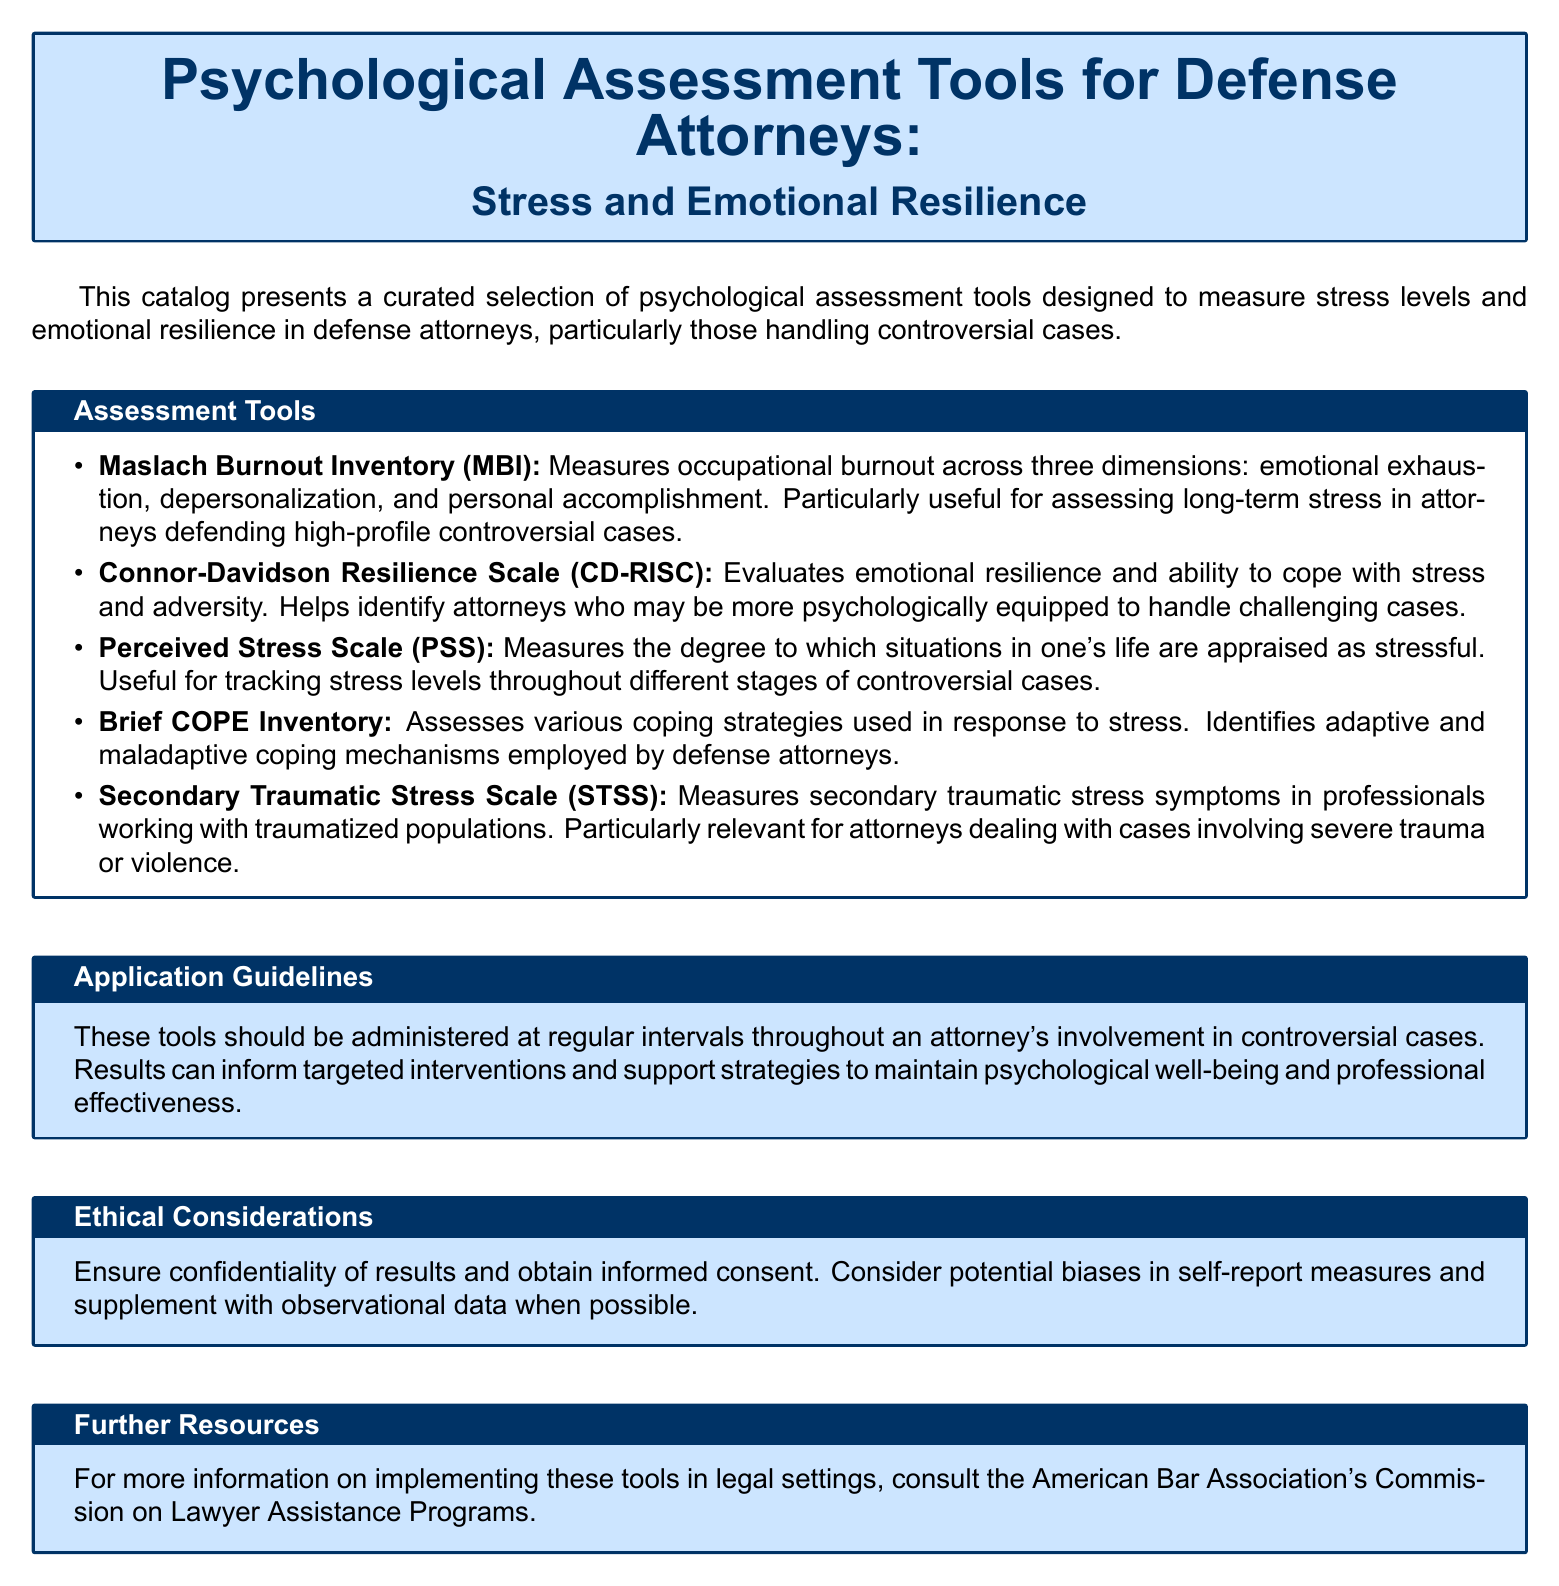What are the three dimensions measured by the Maslach Burnout Inventory? The three dimensions of the Maslach Burnout Inventory are emotional exhaustion, depersonalization, and personal accomplishment.
Answer: emotional exhaustion, depersonalization, personal accomplishment What does the Connor-Davidson Resilience Scale evaluate? The Connor-Davidson Resilience Scale evaluates emotional resilience and ability to cope with stress and adversity.
Answer: emotional resilience What is the purpose of the Perceived Stress Scale? The Perceived Stress Scale measures the degree to which situations in one's life are appraised as stressful.
Answer: appraised stress Which assessment tool identifies adaptive and maladaptive coping mechanisms? The Brief COPE Inventory assesses various coping strategies and identifies adaptive and maladaptive coping mechanisms.
Answer: Brief COPE Inventory What specific symptoms does the Secondary Traumatic Stress Scale measure? The Secondary Traumatic Stress Scale measures secondary traumatic stress symptoms in professionals working with traumatized populations.
Answer: secondary traumatic stress symptoms How often should these tools be administered during controversial cases? The tools should be administered at regular intervals throughout an attorney's involvement in controversial cases.
Answer: regular intervals What is a key ethical consideration mentioned in the document? A key ethical consideration is ensuring confidentiality of results and obtaining informed consent.
Answer: confidentiality Who is the recommended resource for more information on implementing these tools? The recommended resource for more information is the American Bar Association's Commission on Lawyer Assistance Programs.
Answer: American Bar Association's Commission on Lawyer Assistance Programs 